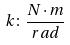<formula> <loc_0><loc_0><loc_500><loc_500>k \colon \frac { N \cdot m } { r a d }</formula> 